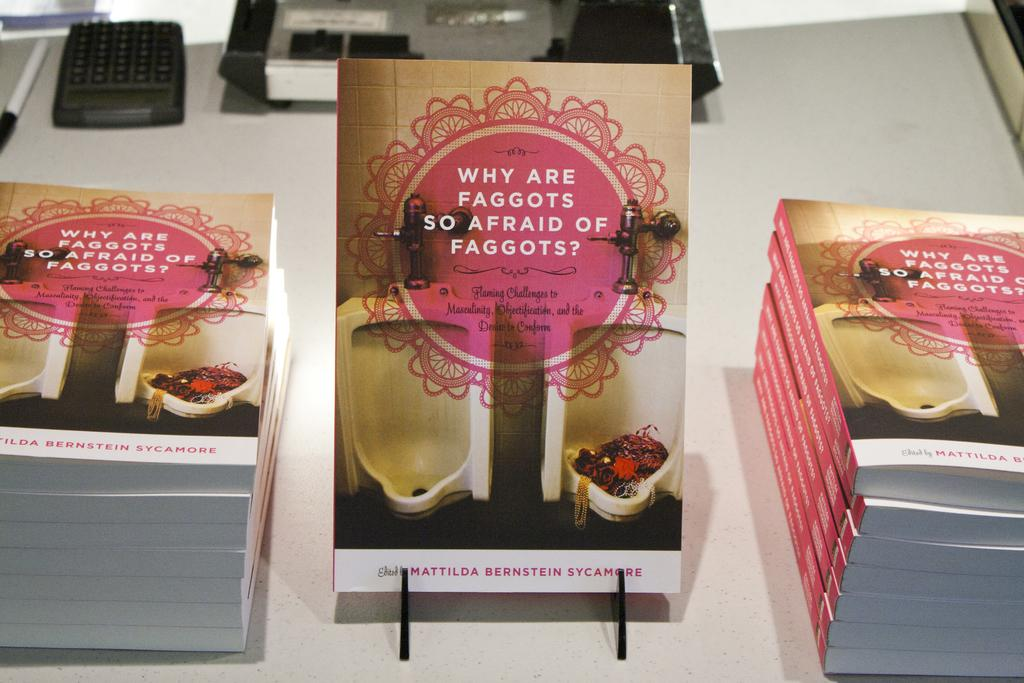What type of objects can be seen in the image? There are books and a pen in the image. What color are the books and pen? The objects are black color objects in the image. What is the color of the surface on which the objects are placed? The objects are on a white color surface. Can you hear the sound of a friend in the image? There is no sound or friend present in the image; it only shows books, a pen, and a white surface. 